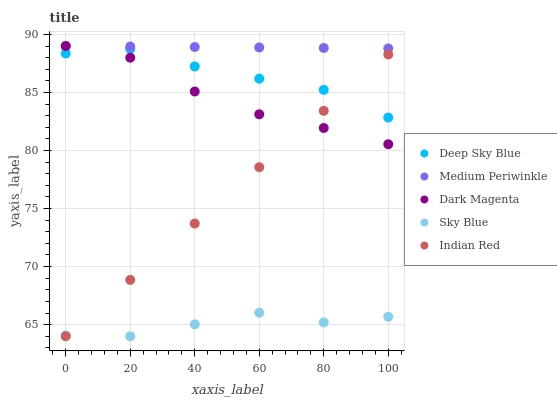Does Sky Blue have the minimum area under the curve?
Answer yes or no. Yes. Does Medium Periwinkle have the maximum area under the curve?
Answer yes or no. Yes. Does Medium Periwinkle have the minimum area under the curve?
Answer yes or no. No. Does Sky Blue have the maximum area under the curve?
Answer yes or no. No. Is Indian Red the smoothest?
Answer yes or no. Yes. Is Sky Blue the roughest?
Answer yes or no. Yes. Is Medium Periwinkle the smoothest?
Answer yes or no. No. Is Medium Periwinkle the roughest?
Answer yes or no. No. Does Indian Red have the lowest value?
Answer yes or no. Yes. Does Medium Periwinkle have the lowest value?
Answer yes or no. No. Does Dark Magenta have the highest value?
Answer yes or no. Yes. Does Sky Blue have the highest value?
Answer yes or no. No. Is Sky Blue less than Medium Periwinkle?
Answer yes or no. Yes. Is Dark Magenta greater than Sky Blue?
Answer yes or no. Yes. Does Deep Sky Blue intersect Indian Red?
Answer yes or no. Yes. Is Deep Sky Blue less than Indian Red?
Answer yes or no. No. Is Deep Sky Blue greater than Indian Red?
Answer yes or no. No. Does Sky Blue intersect Medium Periwinkle?
Answer yes or no. No. 